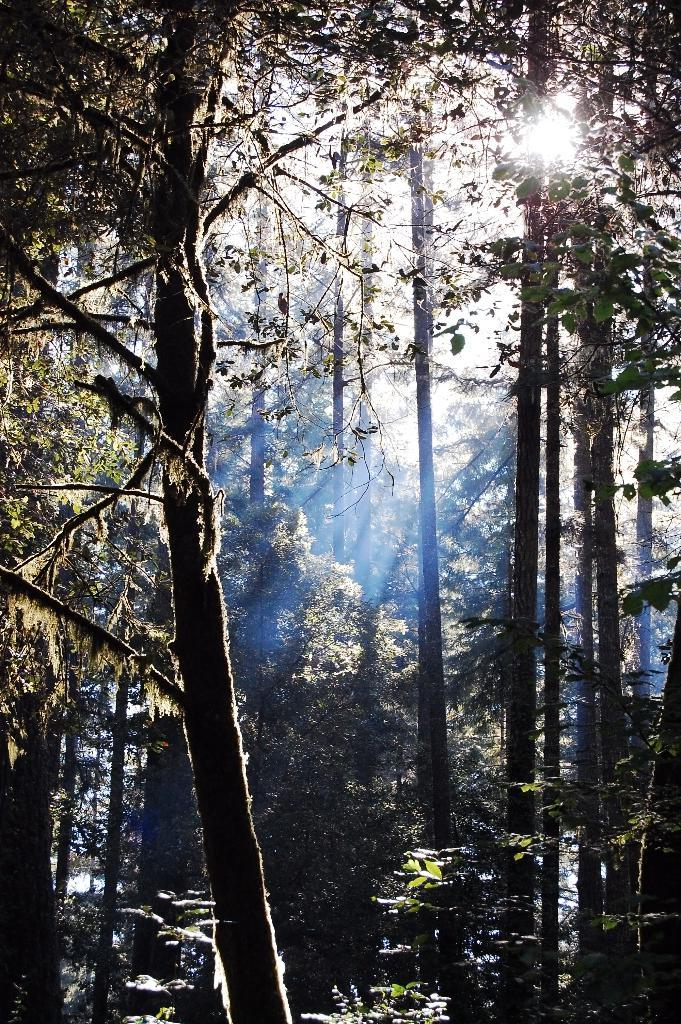What type of vegetation can be seen in the image? There are trees in the image. What part of the natural environment is visible in the image? The sky is visible in the image. What colors can be seen in the sky? The sky has a white and blue color. What type of teeth can be seen in the image? There are no teeth present in the image. What month is depicted in the image? The image does not depict a specific month; it shows trees and the sky. 